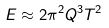Convert formula to latex. <formula><loc_0><loc_0><loc_500><loc_500>E \approx 2 \pi ^ { 2 } Q ^ { 3 } T ^ { 2 }</formula> 